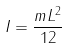Convert formula to latex. <formula><loc_0><loc_0><loc_500><loc_500>I = \frac { m L ^ { 2 } } { 1 2 }</formula> 